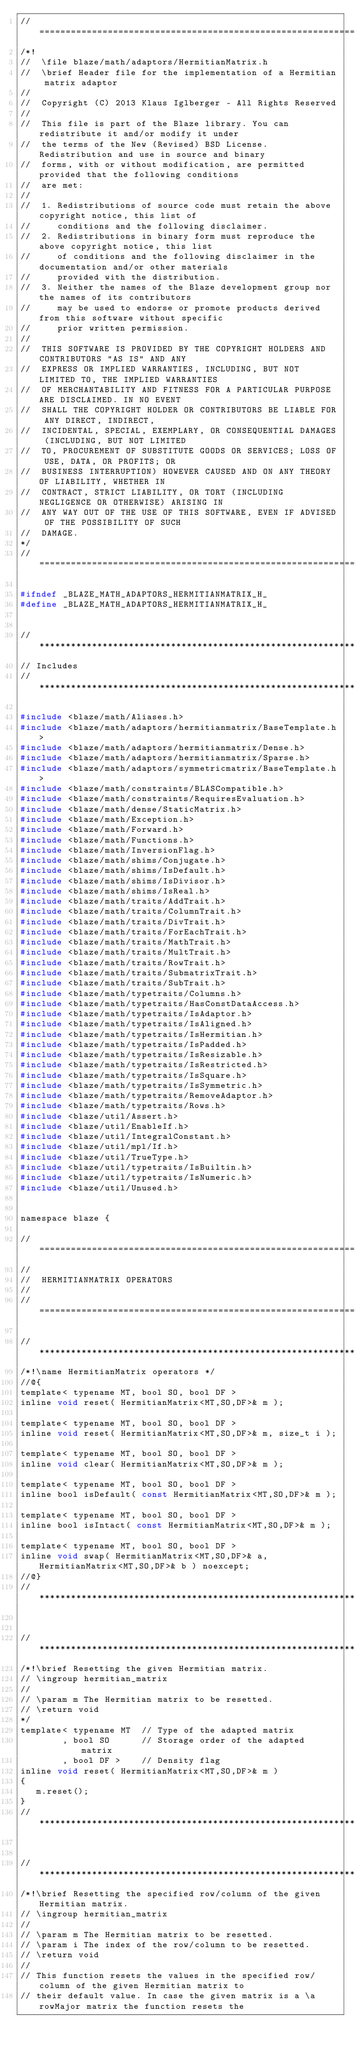Convert code to text. <code><loc_0><loc_0><loc_500><loc_500><_C_>//=================================================================================================
/*!
//  \file blaze/math/adaptors/HermitianMatrix.h
//  \brief Header file for the implementation of a Hermitian matrix adaptor
//
//  Copyright (C) 2013 Klaus Iglberger - All Rights Reserved
//
//  This file is part of the Blaze library. You can redistribute it and/or modify it under
//  the terms of the New (Revised) BSD License. Redistribution and use in source and binary
//  forms, with or without modification, are permitted provided that the following conditions
//  are met:
//
//  1. Redistributions of source code must retain the above copyright notice, this list of
//     conditions and the following disclaimer.
//  2. Redistributions in binary form must reproduce the above copyright notice, this list
//     of conditions and the following disclaimer in the documentation and/or other materials
//     provided with the distribution.
//  3. Neither the names of the Blaze development group nor the names of its contributors
//     may be used to endorse or promote products derived from this software without specific
//     prior written permission.
//
//  THIS SOFTWARE IS PROVIDED BY THE COPYRIGHT HOLDERS AND CONTRIBUTORS "AS IS" AND ANY
//  EXPRESS OR IMPLIED WARRANTIES, INCLUDING, BUT NOT LIMITED TO, THE IMPLIED WARRANTIES
//  OF MERCHANTABILITY AND FITNESS FOR A PARTICULAR PURPOSE ARE DISCLAIMED. IN NO EVENT
//  SHALL THE COPYRIGHT HOLDER OR CONTRIBUTORS BE LIABLE FOR ANY DIRECT, INDIRECT,
//  INCIDENTAL, SPECIAL, EXEMPLARY, OR CONSEQUENTIAL DAMAGES (INCLUDING, BUT NOT LIMITED
//  TO, PROCUREMENT OF SUBSTITUTE GOODS OR SERVICES; LOSS OF USE, DATA, OR PROFITS; OR
//  BUSINESS INTERRUPTION) HOWEVER CAUSED AND ON ANY THEORY OF LIABILITY, WHETHER IN
//  CONTRACT, STRICT LIABILITY, OR TORT (INCLUDING NEGLIGENCE OR OTHERWISE) ARISING IN
//  ANY WAY OUT OF THE USE OF THIS SOFTWARE, EVEN IF ADVISED OF THE POSSIBILITY OF SUCH
//  DAMAGE.
*/
//=================================================================================================

#ifndef _BLAZE_MATH_ADAPTORS_HERMITIANMATRIX_H_
#define _BLAZE_MATH_ADAPTORS_HERMITIANMATRIX_H_


//*************************************************************************************************
// Includes
//*************************************************************************************************

#include <blaze/math/Aliases.h>
#include <blaze/math/adaptors/hermitianmatrix/BaseTemplate.h>
#include <blaze/math/adaptors/hermitianmatrix/Dense.h>
#include <blaze/math/adaptors/hermitianmatrix/Sparse.h>
#include <blaze/math/adaptors/symmetricmatrix/BaseTemplate.h>
#include <blaze/math/constraints/BLASCompatible.h>
#include <blaze/math/constraints/RequiresEvaluation.h>
#include <blaze/math/dense/StaticMatrix.h>
#include <blaze/math/Exception.h>
#include <blaze/math/Forward.h>
#include <blaze/math/Functions.h>
#include <blaze/math/InversionFlag.h>
#include <blaze/math/shims/Conjugate.h>
#include <blaze/math/shims/IsDefault.h>
#include <blaze/math/shims/IsDivisor.h>
#include <blaze/math/shims/IsReal.h>
#include <blaze/math/traits/AddTrait.h>
#include <blaze/math/traits/ColumnTrait.h>
#include <blaze/math/traits/DivTrait.h>
#include <blaze/math/traits/ForEachTrait.h>
#include <blaze/math/traits/MathTrait.h>
#include <blaze/math/traits/MultTrait.h>
#include <blaze/math/traits/RowTrait.h>
#include <blaze/math/traits/SubmatrixTrait.h>
#include <blaze/math/traits/SubTrait.h>
#include <blaze/math/typetraits/Columns.h>
#include <blaze/math/typetraits/HasConstDataAccess.h>
#include <blaze/math/typetraits/IsAdaptor.h>
#include <blaze/math/typetraits/IsAligned.h>
#include <blaze/math/typetraits/IsHermitian.h>
#include <blaze/math/typetraits/IsPadded.h>
#include <blaze/math/typetraits/IsResizable.h>
#include <blaze/math/typetraits/IsRestricted.h>
#include <blaze/math/typetraits/IsSquare.h>
#include <blaze/math/typetraits/IsSymmetric.h>
#include <blaze/math/typetraits/RemoveAdaptor.h>
#include <blaze/math/typetraits/Rows.h>
#include <blaze/util/Assert.h>
#include <blaze/util/EnableIf.h>
#include <blaze/util/IntegralConstant.h>
#include <blaze/util/mpl/If.h>
#include <blaze/util/TrueType.h>
#include <blaze/util/typetraits/IsBuiltin.h>
#include <blaze/util/typetraits/IsNumeric.h>
#include <blaze/util/Unused.h>


namespace blaze {

//=================================================================================================
//
//  HERMITIANMATRIX OPERATORS
//
//=================================================================================================

//*************************************************************************************************
/*!\name HermitianMatrix operators */
//@{
template< typename MT, bool SO, bool DF >
inline void reset( HermitianMatrix<MT,SO,DF>& m );

template< typename MT, bool SO, bool DF >
inline void reset( HermitianMatrix<MT,SO,DF>& m, size_t i );

template< typename MT, bool SO, bool DF >
inline void clear( HermitianMatrix<MT,SO,DF>& m );

template< typename MT, bool SO, bool DF >
inline bool isDefault( const HermitianMatrix<MT,SO,DF>& m );

template< typename MT, bool SO, bool DF >
inline bool isIntact( const HermitianMatrix<MT,SO,DF>& m );

template< typename MT, bool SO, bool DF >
inline void swap( HermitianMatrix<MT,SO,DF>& a, HermitianMatrix<MT,SO,DF>& b ) noexcept;
//@}
//*************************************************************************************************


//*************************************************************************************************
/*!\brief Resetting the given Hermitian matrix.
// \ingroup hermitian_matrix
//
// \param m The Hermitian matrix to be resetted.
// \return void
*/
template< typename MT  // Type of the adapted matrix
        , bool SO      // Storage order of the adapted matrix
        , bool DF >    // Density flag
inline void reset( HermitianMatrix<MT,SO,DF>& m )
{
   m.reset();
}
//*************************************************************************************************


//*************************************************************************************************
/*!\brief Resetting the specified row/column of the given Hermitian matrix.
// \ingroup hermitian_matrix
//
// \param m The Hermitian matrix to be resetted.
// \param i The index of the row/column to be resetted.
// \return void
//
// This function resets the values in the specified row/column of the given Hermitian matrix to
// their default value. In case the given matrix is a \a rowMajor matrix the function resets the</code> 